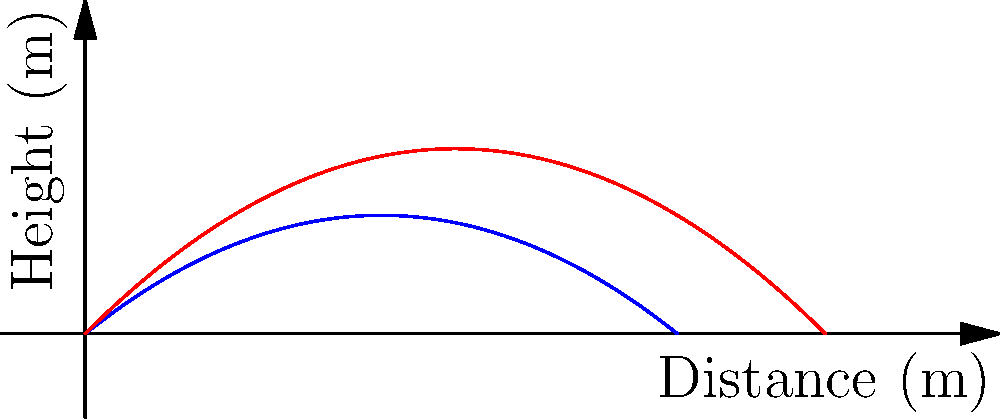A soccer player kicks a ball from ground level with an initial velocity of 20 m/s at two different angles: 30° and 45°. Using the graph, which shows the trajectories of both kicks, determine the difference in horizontal distance traveled by the ball between the two kicks. Assume air resistance is negligible. To solve this problem, we need to follow these steps:

1) Identify the horizontal distances for each kick:
   - For the 30° kick (blue curve), the ball reaches the ground at approximately 16 meters.
   - For the 45° kick (red curve), the ball reaches the ground at 20 meters.

2) Calculate the difference:
   $20 \text{ m} - 16 \text{ m} = 4 \text{ m}$

The difference in horizontal distance is 4 meters.

This result aligns with the theory of projectile motion. In the absence of air resistance, a 45° angle maximizes the range of a projectile. Angles smaller or larger than 45° result in shorter ranges, with complementary angles (like 30° and 60°) producing equal ranges.

The graph visually represents this concept, showing how the 45° trajectory reaches further than the 30° trajectory.
Answer: 4 meters 